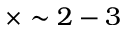Convert formula to latex. <formula><loc_0><loc_0><loc_500><loc_500>\times \sim 2 - 3</formula> 